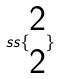<formula> <loc_0><loc_0><loc_500><loc_500>s s \{ \begin{matrix} 2 \\ 2 \end{matrix} \}</formula> 